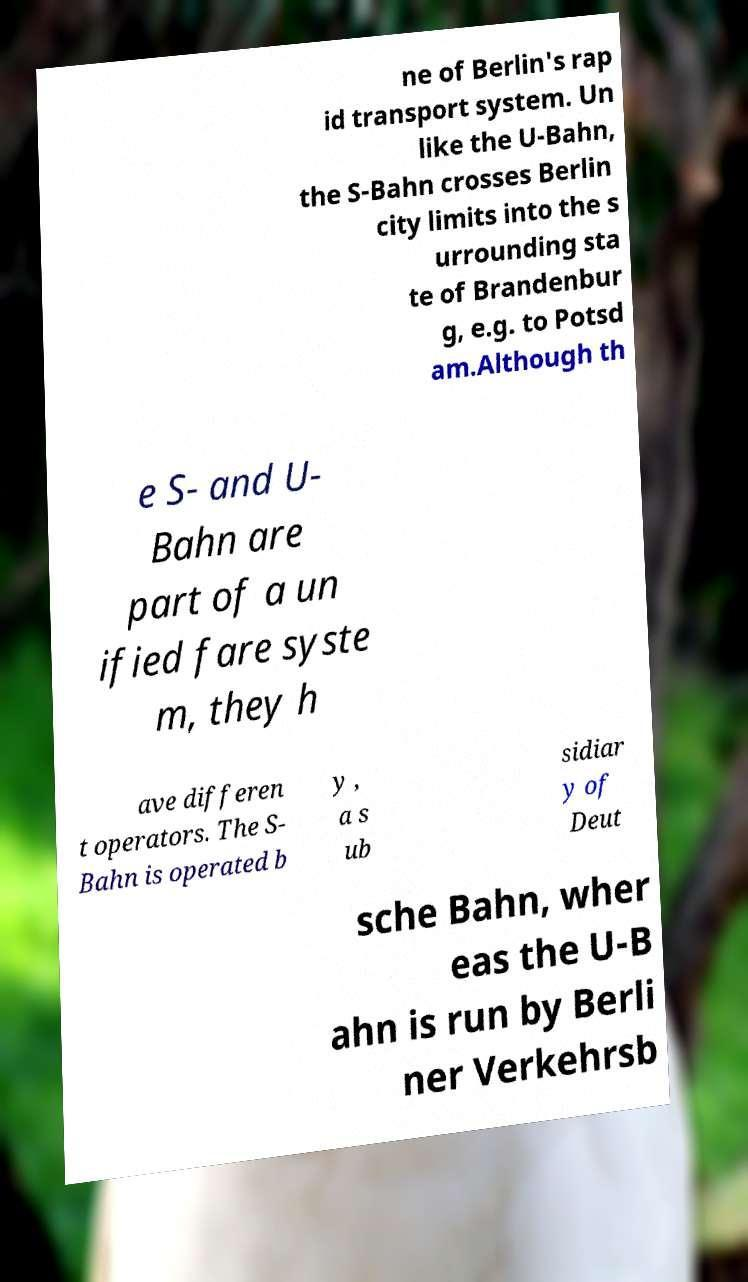What messages or text are displayed in this image? I need them in a readable, typed format. ne of Berlin's rap id transport system. Un like the U-Bahn, the S-Bahn crosses Berlin city limits into the s urrounding sta te of Brandenbur g, e.g. to Potsd am.Although th e S- and U- Bahn are part of a un ified fare syste m, they h ave differen t operators. The S- Bahn is operated b y , a s ub sidiar y of Deut sche Bahn, wher eas the U-B ahn is run by Berli ner Verkehrsb 